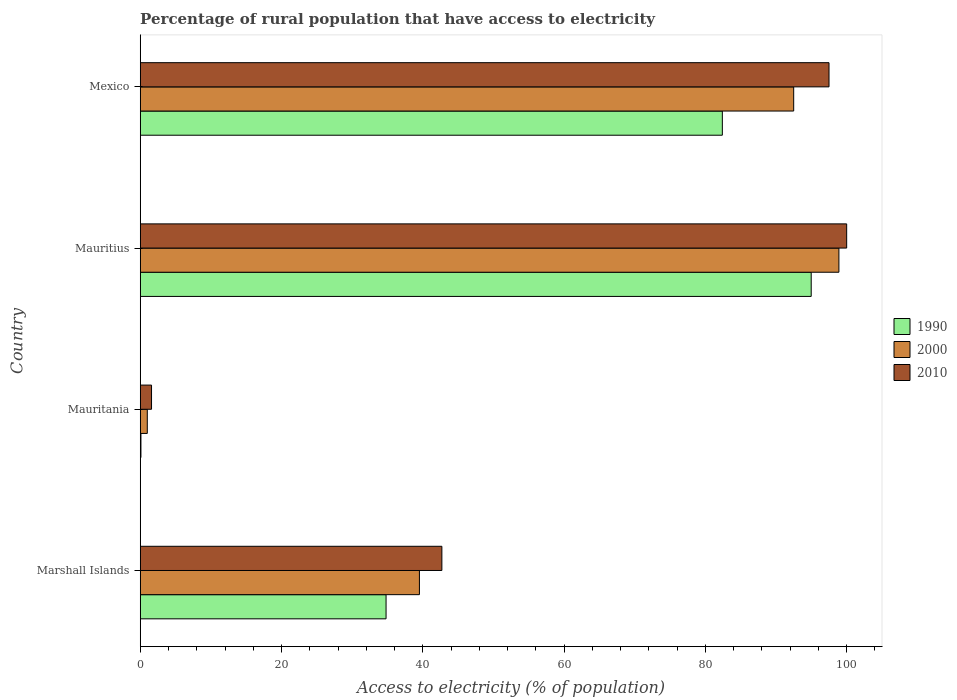How many different coloured bars are there?
Provide a short and direct response. 3. How many groups of bars are there?
Your answer should be very brief. 4. Are the number of bars on each tick of the Y-axis equal?
Your answer should be compact. Yes. How many bars are there on the 4th tick from the bottom?
Keep it short and to the point. 3. What is the percentage of rural population that have access to electricity in 2000 in Marshall Islands?
Ensure brevity in your answer.  39.52. Across all countries, what is the maximum percentage of rural population that have access to electricity in 2000?
Offer a terse response. 98.9. In which country was the percentage of rural population that have access to electricity in 2010 maximum?
Offer a very short reply. Mauritius. In which country was the percentage of rural population that have access to electricity in 2000 minimum?
Make the answer very short. Mauritania. What is the total percentage of rural population that have access to electricity in 2010 in the graph?
Your response must be concise. 241.8. What is the difference between the percentage of rural population that have access to electricity in 1990 in Mauritius and that in Mexico?
Offer a very short reply. 12.58. What is the difference between the percentage of rural population that have access to electricity in 2000 in Marshall Islands and the percentage of rural population that have access to electricity in 2010 in Mexico?
Your answer should be compact. -57.98. What is the average percentage of rural population that have access to electricity in 2000 per country?
Provide a succinct answer. 57.98. What is the difference between the percentage of rural population that have access to electricity in 2000 and percentage of rural population that have access to electricity in 2010 in Marshall Islands?
Ensure brevity in your answer.  -3.18. In how many countries, is the percentage of rural population that have access to electricity in 2000 greater than 32 %?
Make the answer very short. 3. What is the ratio of the percentage of rural population that have access to electricity in 1990 in Marshall Islands to that in Mauritius?
Offer a terse response. 0.37. Is the percentage of rural population that have access to electricity in 2000 in Marshall Islands less than that in Mauritania?
Provide a succinct answer. No. What is the difference between the highest and the second highest percentage of rural population that have access to electricity in 2010?
Provide a short and direct response. 2.5. What is the difference between the highest and the lowest percentage of rural population that have access to electricity in 2010?
Your answer should be very brief. 98.4. In how many countries, is the percentage of rural population that have access to electricity in 2010 greater than the average percentage of rural population that have access to electricity in 2010 taken over all countries?
Provide a short and direct response. 2. Is the sum of the percentage of rural population that have access to electricity in 2010 in Marshall Islands and Mauritania greater than the maximum percentage of rural population that have access to electricity in 2000 across all countries?
Provide a succinct answer. No. What does the 2nd bar from the bottom in Marshall Islands represents?
Make the answer very short. 2000. How many bars are there?
Give a very brief answer. 12. Are all the bars in the graph horizontal?
Make the answer very short. Yes. How many countries are there in the graph?
Your answer should be compact. 4. What is the difference between two consecutive major ticks on the X-axis?
Give a very brief answer. 20. Does the graph contain any zero values?
Provide a succinct answer. No. Where does the legend appear in the graph?
Give a very brief answer. Center right. What is the title of the graph?
Provide a short and direct response. Percentage of rural population that have access to electricity. What is the label or title of the X-axis?
Make the answer very short. Access to electricity (% of population). What is the Access to electricity (% of population) of 1990 in Marshall Islands?
Provide a succinct answer. 34.8. What is the Access to electricity (% of population) in 2000 in Marshall Islands?
Give a very brief answer. 39.52. What is the Access to electricity (% of population) of 2010 in Marshall Islands?
Provide a succinct answer. 42.7. What is the Access to electricity (% of population) in 2000 in Mauritania?
Ensure brevity in your answer.  1. What is the Access to electricity (% of population) of 2010 in Mauritania?
Offer a terse response. 1.6. What is the Access to electricity (% of population) in 1990 in Mauritius?
Keep it short and to the point. 94.98. What is the Access to electricity (% of population) of 2000 in Mauritius?
Offer a very short reply. 98.9. What is the Access to electricity (% of population) in 2010 in Mauritius?
Provide a short and direct response. 100. What is the Access to electricity (% of population) of 1990 in Mexico?
Provide a short and direct response. 82.4. What is the Access to electricity (% of population) in 2000 in Mexico?
Make the answer very short. 92.5. What is the Access to electricity (% of population) of 2010 in Mexico?
Your answer should be compact. 97.5. Across all countries, what is the maximum Access to electricity (% of population) in 1990?
Keep it short and to the point. 94.98. Across all countries, what is the maximum Access to electricity (% of population) of 2000?
Offer a very short reply. 98.9. Across all countries, what is the maximum Access to electricity (% of population) of 2010?
Give a very brief answer. 100. Across all countries, what is the minimum Access to electricity (% of population) in 2010?
Your response must be concise. 1.6. What is the total Access to electricity (% of population) of 1990 in the graph?
Offer a terse response. 212.28. What is the total Access to electricity (% of population) in 2000 in the graph?
Offer a very short reply. 231.92. What is the total Access to electricity (% of population) of 2010 in the graph?
Your response must be concise. 241.8. What is the difference between the Access to electricity (% of population) of 1990 in Marshall Islands and that in Mauritania?
Your answer should be very brief. 34.7. What is the difference between the Access to electricity (% of population) in 2000 in Marshall Islands and that in Mauritania?
Offer a terse response. 38.52. What is the difference between the Access to electricity (% of population) in 2010 in Marshall Islands and that in Mauritania?
Your answer should be compact. 41.1. What is the difference between the Access to electricity (% of population) of 1990 in Marshall Islands and that in Mauritius?
Provide a succinct answer. -60.18. What is the difference between the Access to electricity (% of population) of 2000 in Marshall Islands and that in Mauritius?
Your answer should be very brief. -59.38. What is the difference between the Access to electricity (% of population) of 2010 in Marshall Islands and that in Mauritius?
Give a very brief answer. -57.3. What is the difference between the Access to electricity (% of population) in 1990 in Marshall Islands and that in Mexico?
Make the answer very short. -47.6. What is the difference between the Access to electricity (% of population) in 2000 in Marshall Islands and that in Mexico?
Your answer should be very brief. -52.98. What is the difference between the Access to electricity (% of population) of 2010 in Marshall Islands and that in Mexico?
Keep it short and to the point. -54.8. What is the difference between the Access to electricity (% of population) of 1990 in Mauritania and that in Mauritius?
Offer a terse response. -94.88. What is the difference between the Access to electricity (% of population) of 2000 in Mauritania and that in Mauritius?
Your answer should be compact. -97.9. What is the difference between the Access to electricity (% of population) in 2010 in Mauritania and that in Mauritius?
Give a very brief answer. -98.4. What is the difference between the Access to electricity (% of population) in 1990 in Mauritania and that in Mexico?
Keep it short and to the point. -82.3. What is the difference between the Access to electricity (% of population) in 2000 in Mauritania and that in Mexico?
Your response must be concise. -91.5. What is the difference between the Access to electricity (% of population) of 2010 in Mauritania and that in Mexico?
Your answer should be compact. -95.9. What is the difference between the Access to electricity (% of population) of 1990 in Mauritius and that in Mexico?
Offer a very short reply. 12.58. What is the difference between the Access to electricity (% of population) of 2000 in Mauritius and that in Mexico?
Your response must be concise. 6.4. What is the difference between the Access to electricity (% of population) of 2010 in Mauritius and that in Mexico?
Your answer should be very brief. 2.5. What is the difference between the Access to electricity (% of population) of 1990 in Marshall Islands and the Access to electricity (% of population) of 2000 in Mauritania?
Ensure brevity in your answer.  33.8. What is the difference between the Access to electricity (% of population) in 1990 in Marshall Islands and the Access to electricity (% of population) in 2010 in Mauritania?
Your answer should be very brief. 33.2. What is the difference between the Access to electricity (% of population) of 2000 in Marshall Islands and the Access to electricity (% of population) of 2010 in Mauritania?
Provide a succinct answer. 37.92. What is the difference between the Access to electricity (% of population) in 1990 in Marshall Islands and the Access to electricity (% of population) in 2000 in Mauritius?
Keep it short and to the point. -64.1. What is the difference between the Access to electricity (% of population) of 1990 in Marshall Islands and the Access to electricity (% of population) of 2010 in Mauritius?
Offer a terse response. -65.2. What is the difference between the Access to electricity (% of population) of 2000 in Marshall Islands and the Access to electricity (% of population) of 2010 in Mauritius?
Keep it short and to the point. -60.48. What is the difference between the Access to electricity (% of population) of 1990 in Marshall Islands and the Access to electricity (% of population) of 2000 in Mexico?
Your response must be concise. -57.7. What is the difference between the Access to electricity (% of population) of 1990 in Marshall Islands and the Access to electricity (% of population) of 2010 in Mexico?
Your response must be concise. -62.7. What is the difference between the Access to electricity (% of population) in 2000 in Marshall Islands and the Access to electricity (% of population) in 2010 in Mexico?
Offer a very short reply. -57.98. What is the difference between the Access to electricity (% of population) of 1990 in Mauritania and the Access to electricity (% of population) of 2000 in Mauritius?
Offer a terse response. -98.8. What is the difference between the Access to electricity (% of population) in 1990 in Mauritania and the Access to electricity (% of population) in 2010 in Mauritius?
Provide a succinct answer. -99.9. What is the difference between the Access to electricity (% of population) of 2000 in Mauritania and the Access to electricity (% of population) of 2010 in Mauritius?
Offer a very short reply. -99. What is the difference between the Access to electricity (% of population) in 1990 in Mauritania and the Access to electricity (% of population) in 2000 in Mexico?
Your answer should be very brief. -92.4. What is the difference between the Access to electricity (% of population) in 1990 in Mauritania and the Access to electricity (% of population) in 2010 in Mexico?
Provide a short and direct response. -97.4. What is the difference between the Access to electricity (% of population) in 2000 in Mauritania and the Access to electricity (% of population) in 2010 in Mexico?
Give a very brief answer. -96.5. What is the difference between the Access to electricity (% of population) of 1990 in Mauritius and the Access to electricity (% of population) of 2000 in Mexico?
Make the answer very short. 2.48. What is the difference between the Access to electricity (% of population) in 1990 in Mauritius and the Access to electricity (% of population) in 2010 in Mexico?
Keep it short and to the point. -2.52. What is the difference between the Access to electricity (% of population) of 2000 in Mauritius and the Access to electricity (% of population) of 2010 in Mexico?
Your response must be concise. 1.4. What is the average Access to electricity (% of population) of 1990 per country?
Ensure brevity in your answer.  53.07. What is the average Access to electricity (% of population) of 2000 per country?
Your answer should be very brief. 57.98. What is the average Access to electricity (% of population) in 2010 per country?
Provide a succinct answer. 60.45. What is the difference between the Access to electricity (% of population) in 1990 and Access to electricity (% of population) in 2000 in Marshall Islands?
Provide a short and direct response. -4.72. What is the difference between the Access to electricity (% of population) of 1990 and Access to electricity (% of population) of 2010 in Marshall Islands?
Your response must be concise. -7.9. What is the difference between the Access to electricity (% of population) of 2000 and Access to electricity (% of population) of 2010 in Marshall Islands?
Provide a short and direct response. -3.18. What is the difference between the Access to electricity (% of population) of 1990 and Access to electricity (% of population) of 2000 in Mauritania?
Your answer should be very brief. -0.9. What is the difference between the Access to electricity (% of population) in 2000 and Access to electricity (% of population) in 2010 in Mauritania?
Make the answer very short. -0.6. What is the difference between the Access to electricity (% of population) in 1990 and Access to electricity (% of population) in 2000 in Mauritius?
Provide a succinct answer. -3.92. What is the difference between the Access to electricity (% of population) in 1990 and Access to electricity (% of population) in 2010 in Mauritius?
Offer a very short reply. -5.02. What is the difference between the Access to electricity (% of population) in 1990 and Access to electricity (% of population) in 2000 in Mexico?
Keep it short and to the point. -10.1. What is the difference between the Access to electricity (% of population) in 1990 and Access to electricity (% of population) in 2010 in Mexico?
Ensure brevity in your answer.  -15.1. What is the ratio of the Access to electricity (% of population) of 1990 in Marshall Islands to that in Mauritania?
Offer a terse response. 347.98. What is the ratio of the Access to electricity (% of population) in 2000 in Marshall Islands to that in Mauritania?
Ensure brevity in your answer.  39.52. What is the ratio of the Access to electricity (% of population) of 2010 in Marshall Islands to that in Mauritania?
Keep it short and to the point. 26.69. What is the ratio of the Access to electricity (% of population) of 1990 in Marshall Islands to that in Mauritius?
Ensure brevity in your answer.  0.37. What is the ratio of the Access to electricity (% of population) in 2000 in Marshall Islands to that in Mauritius?
Your answer should be very brief. 0.4. What is the ratio of the Access to electricity (% of population) in 2010 in Marshall Islands to that in Mauritius?
Provide a succinct answer. 0.43. What is the ratio of the Access to electricity (% of population) of 1990 in Marshall Islands to that in Mexico?
Keep it short and to the point. 0.42. What is the ratio of the Access to electricity (% of population) of 2000 in Marshall Islands to that in Mexico?
Your response must be concise. 0.43. What is the ratio of the Access to electricity (% of population) of 2010 in Marshall Islands to that in Mexico?
Offer a very short reply. 0.44. What is the ratio of the Access to electricity (% of population) in 1990 in Mauritania to that in Mauritius?
Ensure brevity in your answer.  0. What is the ratio of the Access to electricity (% of population) in 2000 in Mauritania to that in Mauritius?
Provide a succinct answer. 0.01. What is the ratio of the Access to electricity (% of population) in 2010 in Mauritania to that in Mauritius?
Provide a succinct answer. 0.02. What is the ratio of the Access to electricity (% of population) in 1990 in Mauritania to that in Mexico?
Provide a short and direct response. 0. What is the ratio of the Access to electricity (% of population) of 2000 in Mauritania to that in Mexico?
Keep it short and to the point. 0.01. What is the ratio of the Access to electricity (% of population) in 2010 in Mauritania to that in Mexico?
Offer a very short reply. 0.02. What is the ratio of the Access to electricity (% of population) in 1990 in Mauritius to that in Mexico?
Keep it short and to the point. 1.15. What is the ratio of the Access to electricity (% of population) of 2000 in Mauritius to that in Mexico?
Your answer should be very brief. 1.07. What is the ratio of the Access to electricity (% of population) of 2010 in Mauritius to that in Mexico?
Your response must be concise. 1.03. What is the difference between the highest and the second highest Access to electricity (% of population) of 1990?
Provide a succinct answer. 12.58. What is the difference between the highest and the second highest Access to electricity (% of population) in 2000?
Ensure brevity in your answer.  6.4. What is the difference between the highest and the second highest Access to electricity (% of population) in 2010?
Ensure brevity in your answer.  2.5. What is the difference between the highest and the lowest Access to electricity (% of population) in 1990?
Offer a terse response. 94.88. What is the difference between the highest and the lowest Access to electricity (% of population) of 2000?
Make the answer very short. 97.9. What is the difference between the highest and the lowest Access to electricity (% of population) of 2010?
Ensure brevity in your answer.  98.4. 